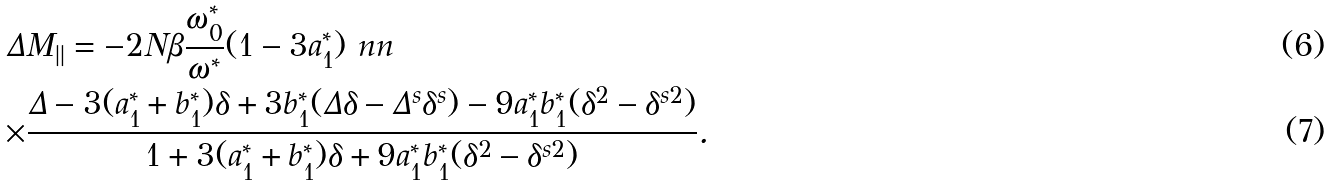<formula> <loc_0><loc_0><loc_500><loc_500>\Delta & M _ { | | } = - 2 N \beta \frac { \omega _ { 0 } ^ { * } } { \omega ^ { * } } ( 1 - 3 a _ { 1 } ^ { * } ) \ n n \\ \times & \frac { \Delta - 3 ( a _ { 1 } ^ { * } + b _ { 1 } ^ { * } ) \delta + 3 b _ { 1 } ^ { * } ( \Delta \delta - \Delta ^ { s } \delta ^ { s } ) - 9 a _ { 1 } ^ { * } b _ { 1 } ^ { * } ( \delta ^ { 2 } - \delta ^ { s 2 } ) } { 1 + 3 ( a _ { 1 } ^ { * } + b _ { 1 } ^ { * } ) \delta + 9 a _ { 1 } ^ { * } b _ { 1 } ^ { * } ( \delta ^ { 2 } - \delta ^ { s 2 } ) } .</formula> 